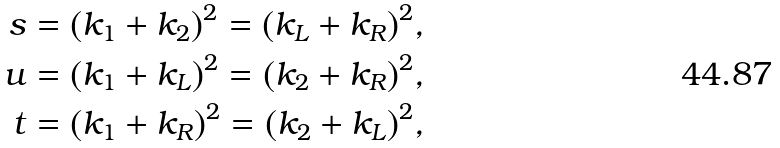Convert formula to latex. <formula><loc_0><loc_0><loc_500><loc_500>s & = ( k _ { 1 } + k _ { 2 } ) ^ { 2 } = ( k _ { L } + k _ { R } ) ^ { 2 } , \\ u & = ( k _ { 1 } + k _ { L } ) ^ { 2 } = ( k _ { 2 } + k _ { R } ) ^ { 2 } , \\ t & = ( k _ { 1 } + k _ { R } ) ^ { 2 } = ( k _ { 2 } + k _ { L } ) ^ { 2 } , \\</formula> 